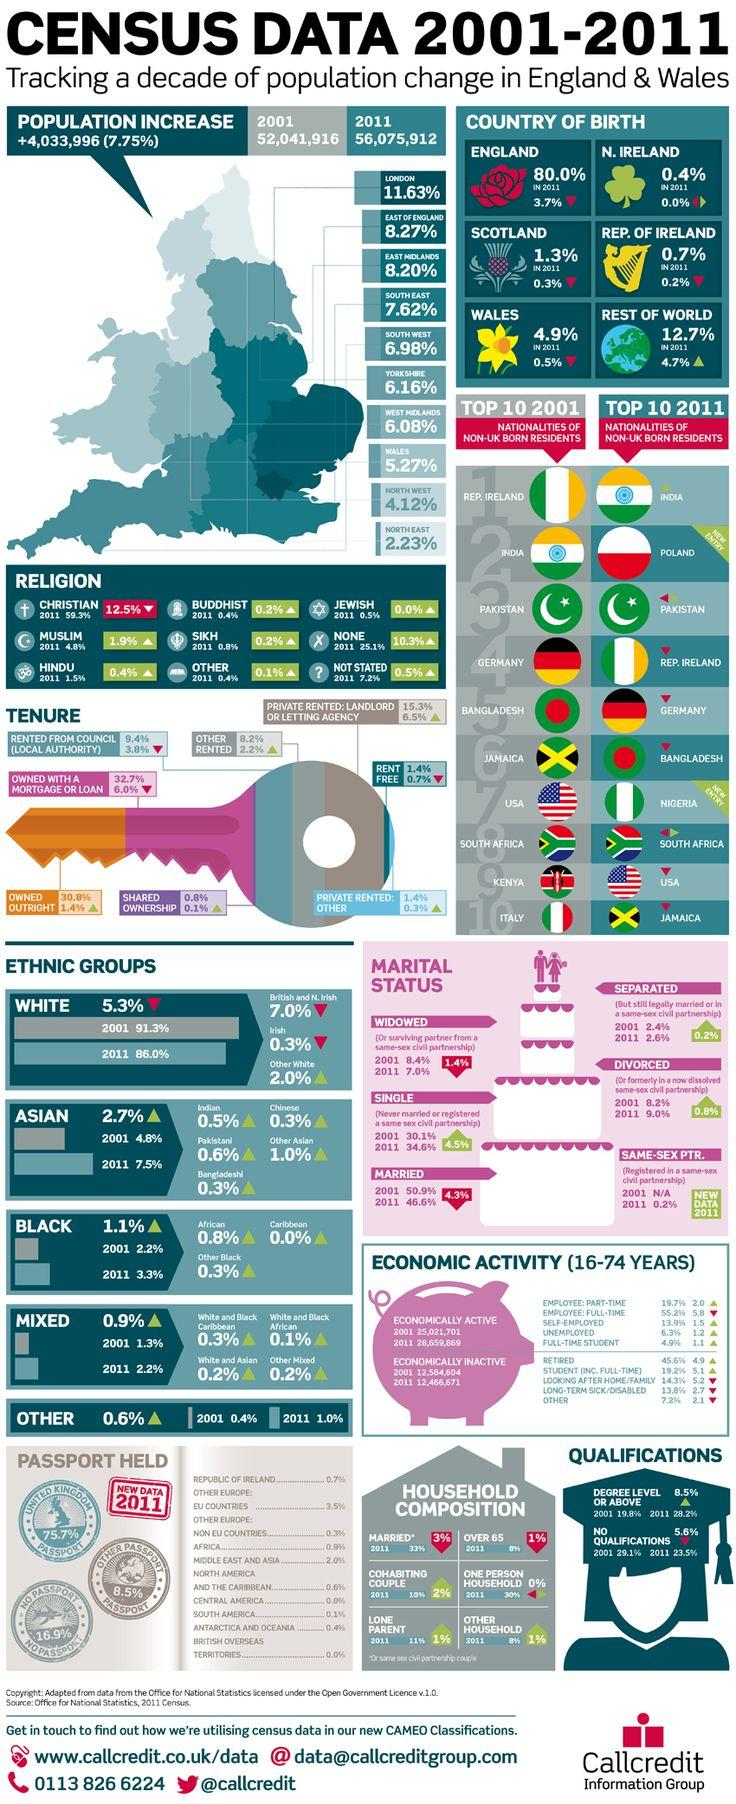Outline some significant characteristics in this image. The combined percentage of white people in 2001 and 2011 was 177.3%. In 2001 and 2011, the combined percentage of black people was 5.5%. In 2011, 80.4% of the people whose birthplace was in England and Northern Ireland were born in those regions. According to the 2011 Census, approximately 2% of the population was born in Scotland and the Republic of Ireland. The combined percentage of Asians in 2001 and 2011 was 12.3%. 